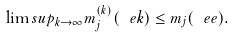<formula> <loc_0><loc_0><loc_500><loc_500>\lim s u p _ { k \to \infty } m _ { j } ^ { ( k ) } ( \ e k ) \leq m _ { j } ( \ e e ) .</formula> 